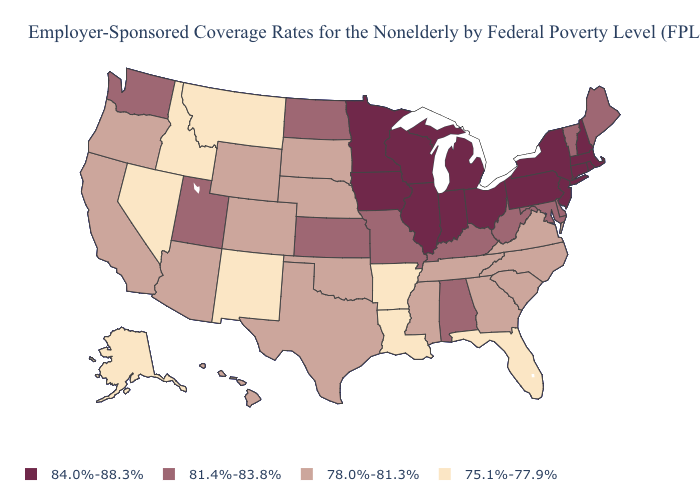Does the first symbol in the legend represent the smallest category?
Short answer required. No. Which states have the highest value in the USA?
Short answer required. Connecticut, Illinois, Indiana, Iowa, Massachusetts, Michigan, Minnesota, New Hampshire, New Jersey, New York, Ohio, Pennsylvania, Rhode Island, Wisconsin. Does Maine have a lower value than Oregon?
Quick response, please. No. How many symbols are there in the legend?
Answer briefly. 4. Name the states that have a value in the range 78.0%-81.3%?
Be succinct. Arizona, California, Colorado, Georgia, Hawaii, Mississippi, Nebraska, North Carolina, Oklahoma, Oregon, South Carolina, South Dakota, Tennessee, Texas, Virginia, Wyoming. Name the states that have a value in the range 84.0%-88.3%?
Keep it brief. Connecticut, Illinois, Indiana, Iowa, Massachusetts, Michigan, Minnesota, New Hampshire, New Jersey, New York, Ohio, Pennsylvania, Rhode Island, Wisconsin. What is the value of Delaware?
Write a very short answer. 81.4%-83.8%. Does Colorado have a lower value than Connecticut?
Write a very short answer. Yes. What is the highest value in states that border Florida?
Answer briefly. 81.4%-83.8%. Does New York have the highest value in the Northeast?
Concise answer only. Yes. Among the states that border Arkansas , which have the highest value?
Write a very short answer. Missouri. What is the value of Maine?
Short answer required. 81.4%-83.8%. What is the value of Mississippi?
Give a very brief answer. 78.0%-81.3%. Among the states that border Connecticut , which have the highest value?
Keep it brief. Massachusetts, New York, Rhode Island. Does Iowa have the lowest value in the MidWest?
Answer briefly. No. 